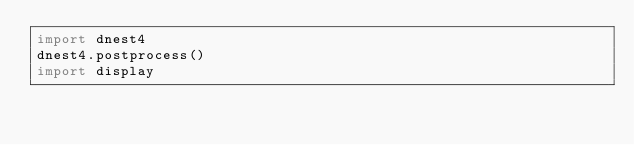Convert code to text. <code><loc_0><loc_0><loc_500><loc_500><_Python_>import dnest4
dnest4.postprocess()
import display

</code> 